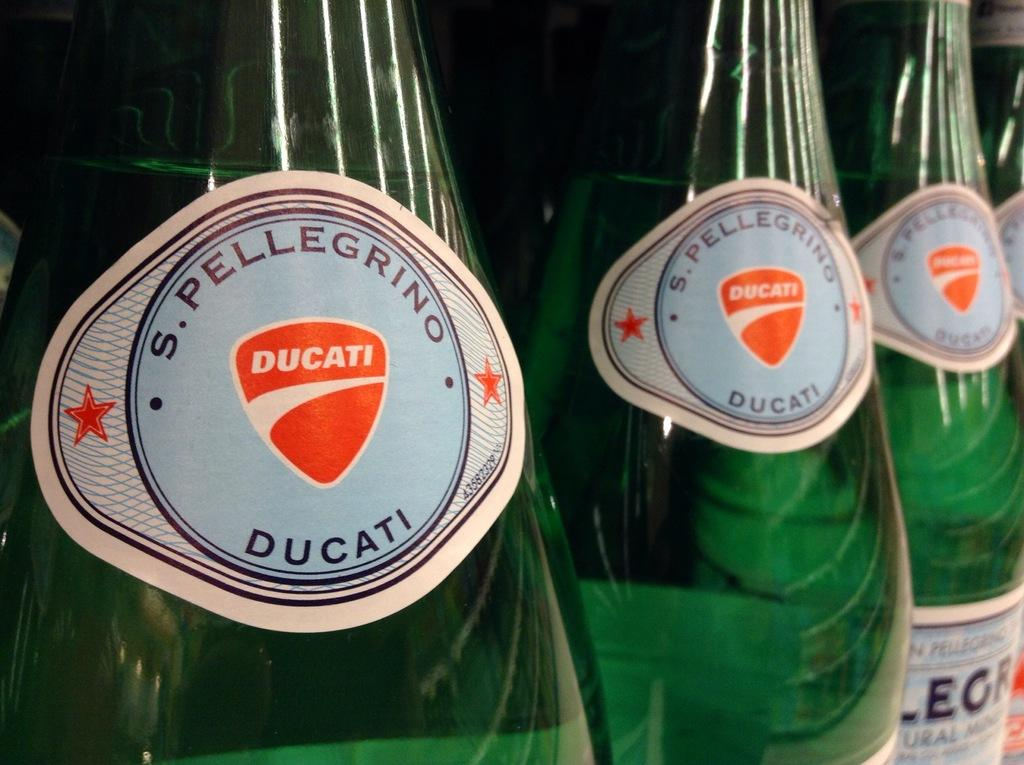<image>
Share a concise interpretation of the image provided. Green bottles of some sort of drink with Ducati brand on the bottle. 